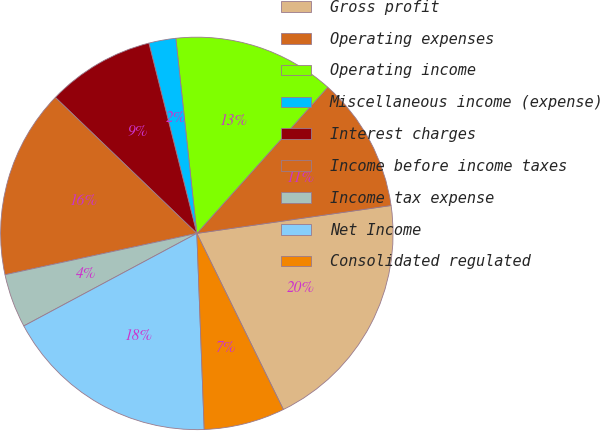Convert chart. <chart><loc_0><loc_0><loc_500><loc_500><pie_chart><fcel>Gross profit<fcel>Operating expenses<fcel>Operating income<fcel>Miscellaneous income (expense)<fcel>Interest charges<fcel>Income before income taxes<fcel>Income tax expense<fcel>Net Income<fcel>Consolidated regulated<nl><fcel>20.0%<fcel>11.11%<fcel>13.33%<fcel>2.22%<fcel>8.89%<fcel>15.56%<fcel>4.44%<fcel>17.78%<fcel>6.67%<nl></chart> 